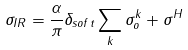Convert formula to latex. <formula><loc_0><loc_0><loc_500><loc_500>\sigma _ { I R } = \frac { \alpha } { \pi } \delta _ { s o f t } \sum _ { k } \sigma _ { o } ^ { k } + \sigma ^ { H }</formula> 